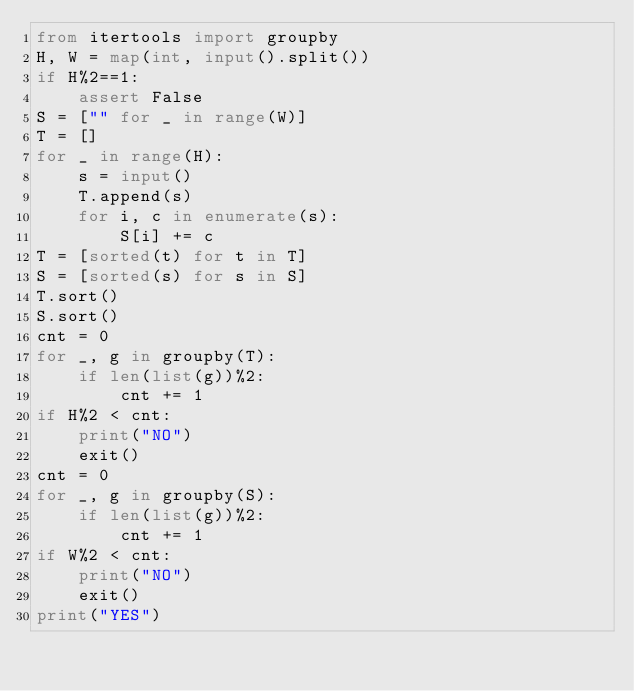Convert code to text. <code><loc_0><loc_0><loc_500><loc_500><_Python_>from itertools import groupby
H, W = map(int, input().split())
if H%2==1:
    assert False
S = ["" for _ in range(W)]
T = []
for _ in range(H):
    s = input()
    T.append(s)
    for i, c in enumerate(s):
        S[i] += c
T = [sorted(t) for t in T]
S = [sorted(s) for s in S]
T.sort()
S.sort()
cnt = 0
for _, g in groupby(T):
    if len(list(g))%2:
        cnt += 1
if H%2 < cnt:
    print("NO")
    exit()
cnt = 0
for _, g in groupby(S):
    if len(list(g))%2:
        cnt += 1
if W%2 < cnt:
    print("NO")
    exit()
print("YES")
</code> 